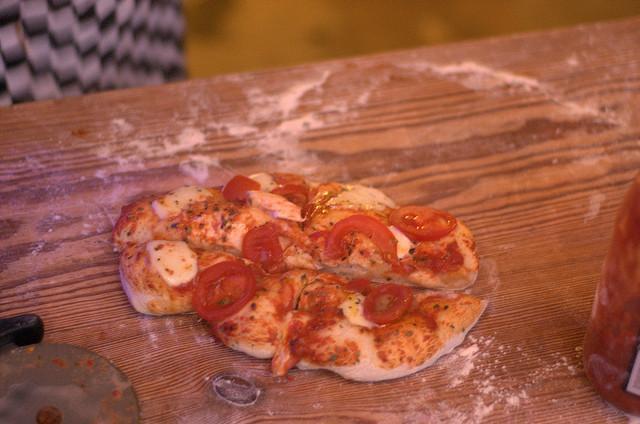How many boys are there?
Give a very brief answer. 0. 